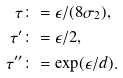<formula> <loc_0><loc_0><loc_500><loc_500>\tau & \colon = \epsilon / ( 8 \sigma _ { 2 } ) , \\ \tau ^ { \prime } & \colon = \epsilon / 2 , \\ \tau ^ { \prime \prime } & \colon = \exp ( \epsilon / d ) .</formula> 